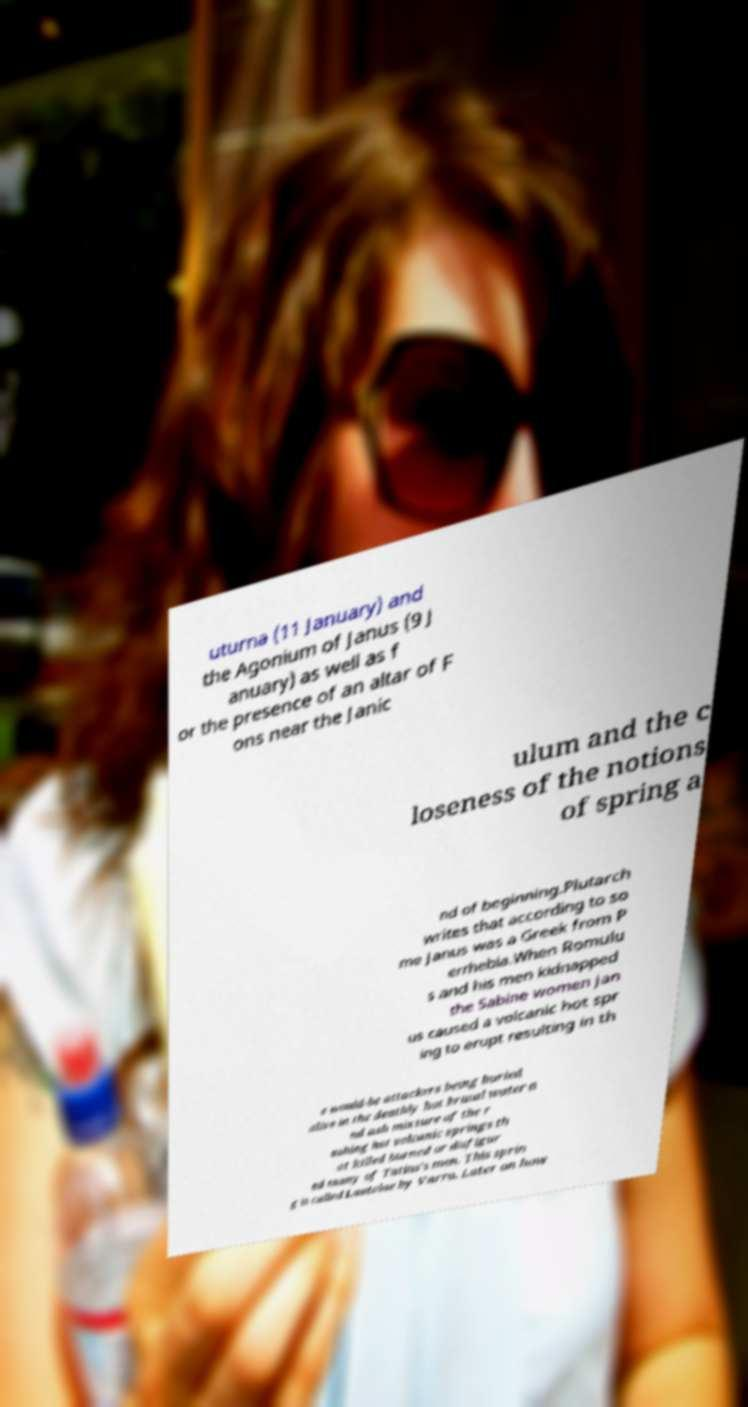Please identify and transcribe the text found in this image. uturna (11 January) and the Agonium of Janus (9 J anuary) as well as f or the presence of an altar of F ons near the Janic ulum and the c loseness of the notions of spring a nd of beginning.Plutarch writes that according to so me Janus was a Greek from P errhebia.When Romulu s and his men kidnapped the Sabine women Jan us caused a volcanic hot spr ing to erupt resulting in th e would-be attackers being buried alive in the deathly hot brutal water a nd ash mixture of the r ushing hot volcanic springs th at killed burned or disfigur ed many of Tatius's men. This sprin g is called Lautolae by Varro. Later on how 